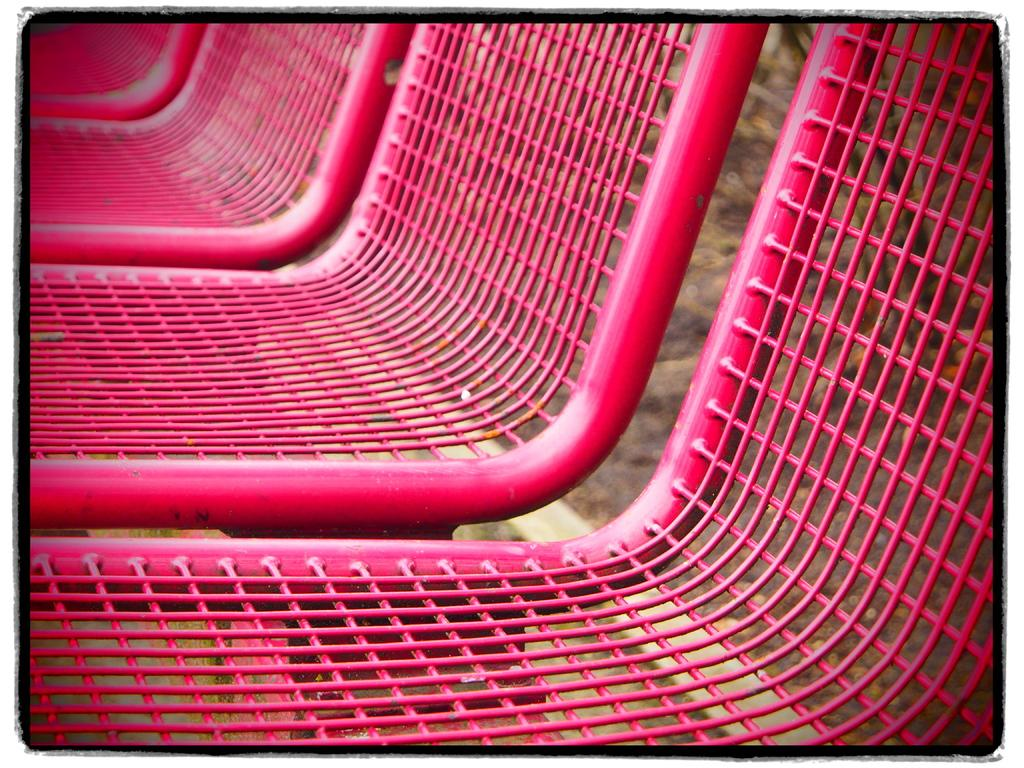What material are the chairs in the image made of? The chairs in the image are made of metal. What color are the chairs? The chairs are pink in color. What can be seen at the bottom of the image? There is ground visible at the bottom of the image. How many kisses can be seen on the dress in the image? There is no dress present in the image, and therefore no kisses can be observed. 